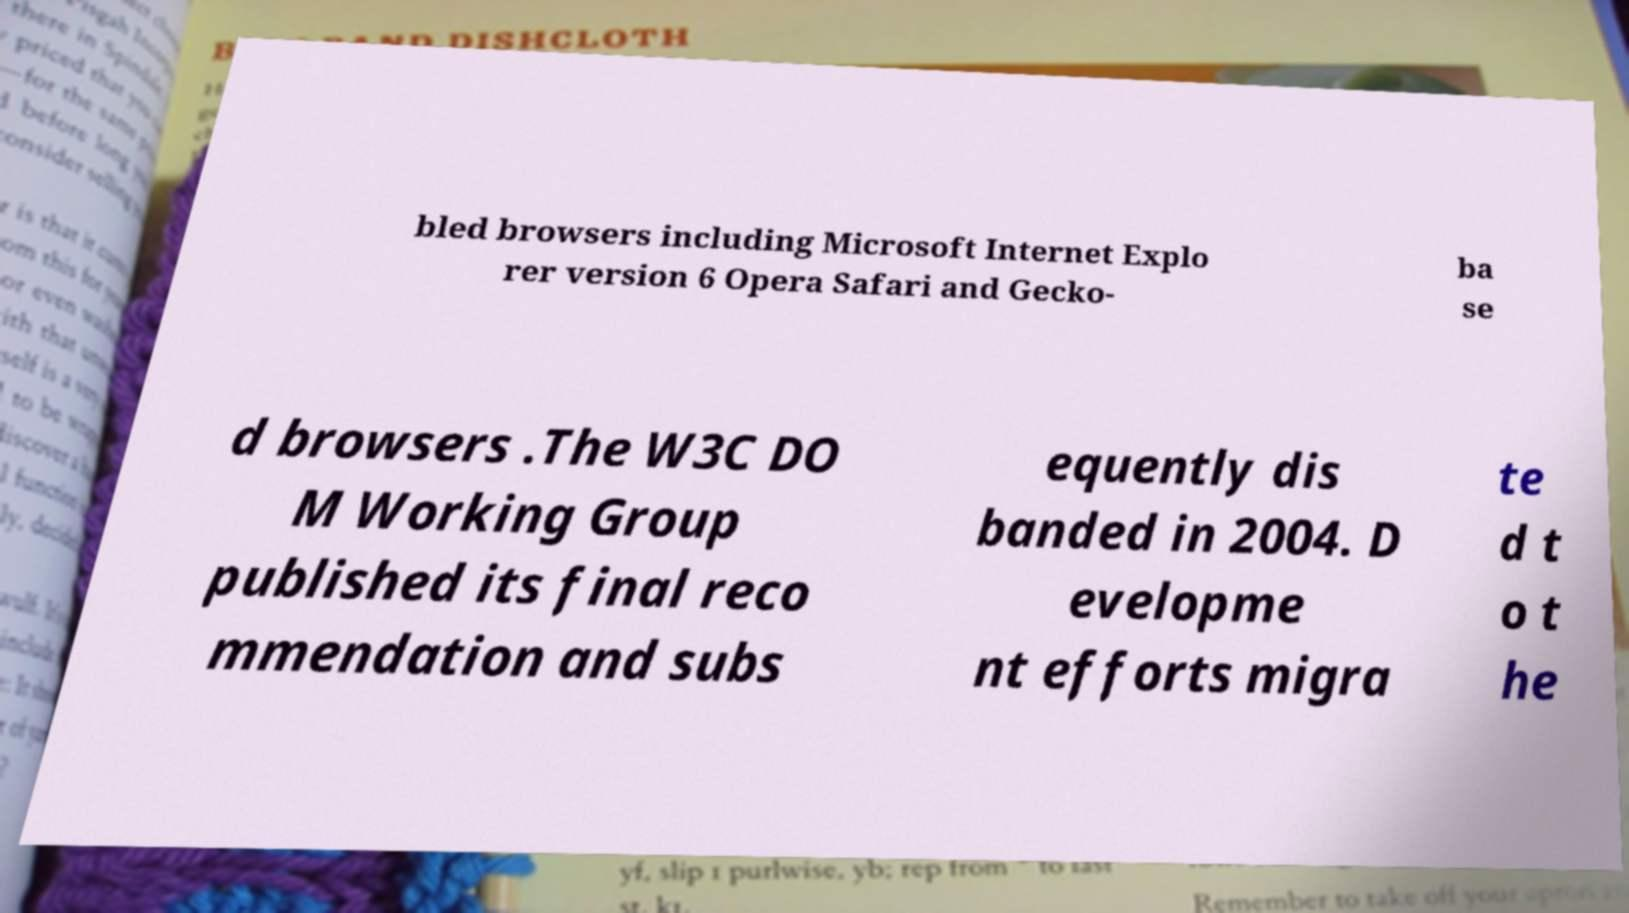Could you extract and type out the text from this image? bled browsers including Microsoft Internet Explo rer version 6 Opera Safari and Gecko- ba se d browsers .The W3C DO M Working Group published its final reco mmendation and subs equently dis banded in 2004. D evelopme nt efforts migra te d t o t he 